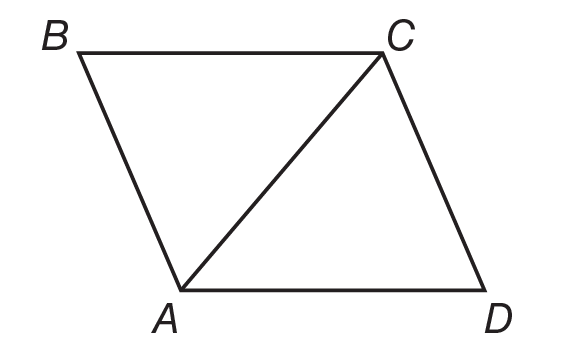Question: Quadrilateral A B C D is a rhombus. If m \angle B C D = 120, find m \angle D A C.
Choices:
A. 30
B. 60
C. 90
D. 120
Answer with the letter. Answer: B 